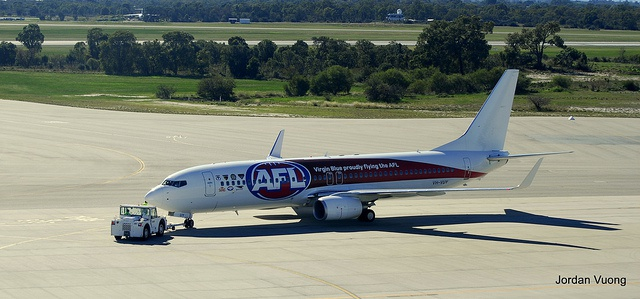Describe the objects in this image and their specific colors. I can see airplane in blue, black, gray, and darkgray tones, truck in blue, black, and gray tones, people in blue, teal, black, and green tones, and people in blue, black, darkgreen, and teal tones in this image. 